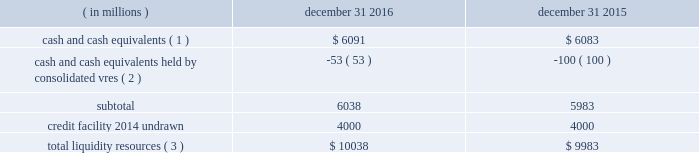Sources of blackrock 2019s operating cash primarily include investment advisory , administration fees and securities lending revenue , performance fees , revenue from blackrock solutions and advisory products and services , other revenue and distribution fees .
Blackrock uses its cash to pay all operating expense , interest and principal on borrowings , income taxes , dividends on blackrock 2019s capital stock , repurchases of the company 2019s stock , capital expenditures and purchases of co-investments and seed investments .
For details of the company 2019s gaap cash flows from operating , investing and financing activities , see the consolidated statements of cash flows contained in part ii , item 8 of this filing .
Cash flows from operating activities , excluding the impact of consolidated sponsored investment funds , primarily include the receipt of investment advisory and administration fees , securities lending revenue and performance fees offset by the payment of operating expenses incurred in the normal course of business , including year-end incentive compensation accrued for in the prior year .
Cash outflows from investing activities , excluding the impact of consolidated sponsored investment funds , for 2016 were $ 58 million and primarily reflected $ 384 million of investment purchases , $ 119 million of purchases of property and equipment and $ 30 million related to an acquisition , partially offset by $ 441 million of net proceeds from sales and maturities of certain investments .
Cash outflows from financing activities , excluding the impact of consolidated sponsored investment funds , for 2016 were $ 2831 million , primarily resulting from $ 1.4 billion of share repurchases , including $ 1.1 billion in open market- transactions and $ 274 million of employee tax withholdings related to employee stock transactions and $ 1.5 billion of cash dividend payments , partially offset by $ 82 million of excess tax benefits from vested stock-based compensation awards .
The company manages its financial condition and funding to maintain appropriate liquidity for the business .
Liquidity resources at december 31 , 2016 and 2015 were as follows : ( in millions ) december 31 , december 31 , cash and cash equivalents ( 1 ) $ 6091 $ 6083 cash and cash equivalents held by consolidated vres ( 2 ) ( 53 ) ( 100 ) .
Total liquidity resources ( 3 ) $ 10038 $ 9983 ( 1 ) the percentage of cash and cash equivalents held by the company 2019s u.s .
Subsidiaries was approximately 50% ( 50 % ) at both december 31 , 2016 and 2015 .
See net capital requirements herein for more information on net capital requirements in certain regulated subsidiaries .
( 2 ) the company cannot readily access such cash to use in its operating activities .
( 3 ) amounts do not reflect year-end incentive compensation accruals of approximately $ 1.3 billion and $ 1.5 billion for 2016 and 2015 , respectively , which were paid in the first quarter of the following year .
Total liquidity resources increased $ 55 million during 2016 , primarily reflecting cash flows from operating activities , partially offset by cash payments of 2015 year-end incentive awards , share repurchases of $ 1.4 billion and cash dividend payments of $ 1.5 billion .
A significant portion of the company 2019s $ 2414 million of total investments , as adjusted , is illiquid in nature and , as such , cannot be readily convertible to cash .
Share repurchases .
The company repurchased 3.3 million common shares in open market-transactions under its share repurchase program for $ 1.1 billion during 2016 .
At december 31 , 2016 , there were 3 million shares still authorized to be repurchased .
In january 2017 , the board of directors approved an increase in the shares that may be repurchased under the company 2019s existing share repurchase program to allow for the repurchase of an additional 6 million shares for a total up to 9 million shares of blackrock common stock .
Net capital requirements .
The company is required to maintain net capital in certain regulated subsidiaries within a number of jurisdictions , which is partially maintained by retaining cash and cash equivalent investments in those subsidiaries or jurisdictions .
As a result , such subsidiaries of the company may be restricted in their ability to transfer cash between different jurisdictions and to their parents .
Additionally , transfers of cash between international jurisdictions , including repatriation to the united states , may have adverse tax consequences that could discourage such transfers .
Blackrock institutional trust company , n.a .
( 201cbtc 201d ) is chartered as a national bank that does not accept client deposits and whose powers are limited to trust and other fiduciary activities .
Btc provides investment management services , including investment advisory and securities lending agency services , to institutional investors and other clients .
Btc is subject to regulatory capital and liquid asset requirements administered by the office of the comptroller of the currency .
At december 31 , 2016 and 2015 , the company was required to maintain approximately $ 1.4 billion and $ 1.1 billion , respectively , in net capital in certain regulated subsidiaries , including btc , entities regulated by the financial conduct authority and prudential regulation authority in the united kingdom , and the company 2019s broker-dealers .
The company was in compliance with all applicable regulatory net capital requirements .
Undistributed earnings of foreign subsidiaries .
As of december 31 , 2016 , the company has not provided for u.s .
Federal and state income taxes on approximately $ 5.3 billion of undistributed earnings of its foreign subsidiaries .
Such earnings are considered indefinitely reinvested outside the united states .
The company 2019s current plans do not demonstrate a need to repatriate these funds .
Short-term borrowings 2016 revolving credit facility .
The company 2019s credit facility has an aggregate commitment amount of $ 4.0 billion and was amended in april 2016 to extend the maturity date to march 2021 ( the 201c2016 credit facility 201d ) .
The 2016 credit facility permits the company to request up to an additional $ 1.0 billion of borrowing capacity , subject to lender credit approval , increasing the overall size of the 2016 credit facility to an aggregate principal amount not to exceed $ 5.0 billion .
Interest on borrowings outstanding accrues at a rate based on the applicable london interbank offered rate plus a spread .
The 2016 credit facility requires the company not to exceed a maximum leverage ratio ( ratio of net debt to .
What is the percentage change in total liquidity resources from 2015 to 2016? 
Computations: ((10038 - 9983) / 9983)
Answer: 0.00551. 